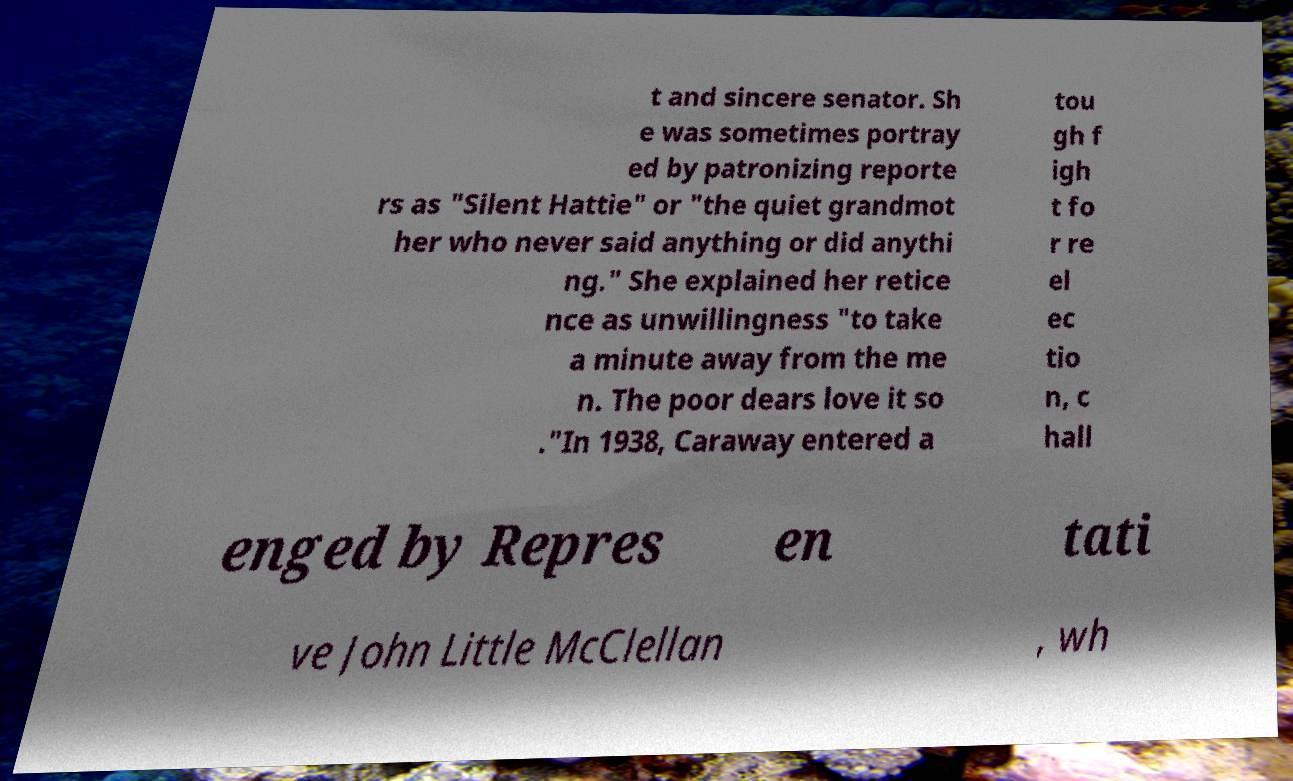Please identify and transcribe the text found in this image. t and sincere senator. Sh e was sometimes portray ed by patronizing reporte rs as "Silent Hattie" or "the quiet grandmot her who never said anything or did anythi ng." She explained her retice nce as unwillingness "to take a minute away from the me n. The poor dears love it so ."In 1938, Caraway entered a tou gh f igh t fo r re el ec tio n, c hall enged by Repres en tati ve John Little McClellan , wh 